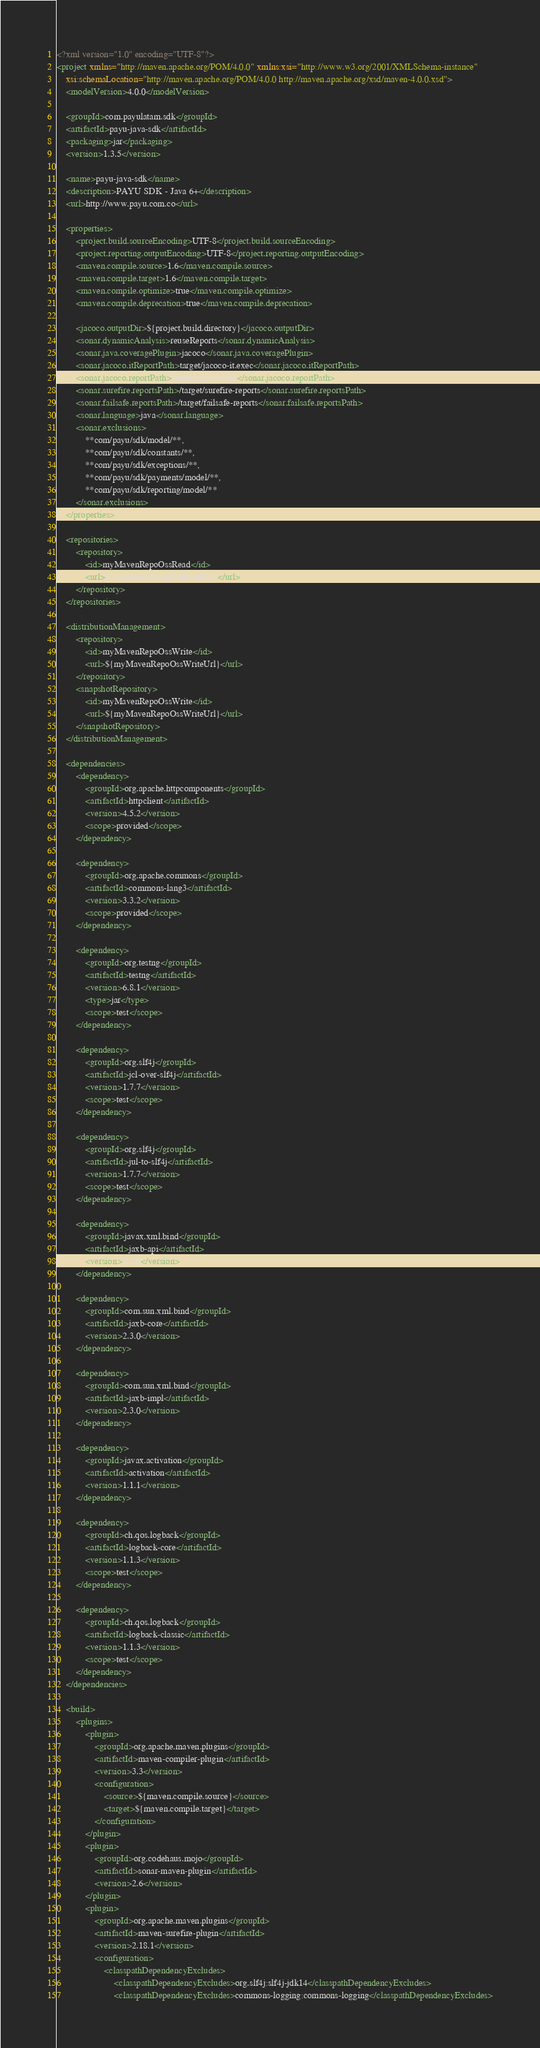Convert code to text. <code><loc_0><loc_0><loc_500><loc_500><_XML_><?xml version="1.0" encoding="UTF-8"?>
<project xmlns="http://maven.apache.org/POM/4.0.0" xmlns:xsi="http://www.w3.org/2001/XMLSchema-instance"
	xsi:schemaLocation="http://maven.apache.org/POM/4.0.0 http://maven.apache.org/xsd/maven-4.0.0.xsd">
	<modelVersion>4.0.0</modelVersion>

	<groupId>com.payulatam.sdk</groupId>
	<artifactId>payu-java-sdk</artifactId>
	<packaging>jar</packaging>
	<version>1.3.5</version>

	<name>payu-java-sdk</name>
	<description>PAYU SDK - Java 6+</description>
	<url>http://www.payu.com.co</url>

	<properties>
		<project.build.sourceEncoding>UTF-8</project.build.sourceEncoding>
		<project.reporting.outputEncoding>UTF-8</project.reporting.outputEncoding>
		<maven.compile.source>1.6</maven.compile.source>
		<maven.compile.target>1.6</maven.compile.target>
		<maven.compile.optimize>true</maven.compile.optimize>
		<maven.compile.deprecation>true</maven.compile.deprecation>

		<jacoco.outputDir>${project.build.directory}</jacoco.outputDir>
		<sonar.dynamicAnalysis>reuseReports</sonar.dynamicAnalysis>
		<sonar.java.coveragePlugin>jacoco</sonar.java.coveragePlugin>
		<sonar.jacoco.itReportPath>target/jacoco-it.exec</sonar.jacoco.itReportPath>
		<sonar.jacoco.reportPath>target/jacoco.exec</sonar.jacoco.reportPath>
		<sonar.surefire.reportsPath>/target/surefire-reports</sonar.surefire.reportsPath>
		<sonar.failsafe.reportsPath>/target/failsafe-reports</sonar.failsafe.reportsPath>
		<sonar.language>java</sonar.language>
		<sonar.exclusions>
			**com/payu/sdk/model/**,
			**com/payu/sdk/constants/**,
			**com/payu/sdk/exceptions/**,
			**com/payu/sdk/payments/model/**,
			**com/payu/sdk/reporting/model/**
		</sonar.exclusions>
	</properties>

	<repositories>
		<repository>
			<id>myMavenRepoOssRead</id>
			<url>${myMavenRepoOssReadUrl}</url>
		</repository>
	</repositories>

	<distributionManagement>
		<repository>
			<id>myMavenRepoOssWrite</id>
			<url>${myMavenRepoOssWriteUrl}</url>
		</repository>
		<snapshotRepository>
			<id>myMavenRepoOssWrite</id>
			<url>${myMavenRepoOssWriteUrl}</url>
		</snapshotRepository>
	</distributionManagement>

	<dependencies>
		<dependency>
			<groupId>org.apache.httpcomponents</groupId>
			<artifactId>httpclient</artifactId>
			<version>4.5.2</version>
			<scope>provided</scope>
		</dependency>

		<dependency>
			<groupId>org.apache.commons</groupId>
			<artifactId>commons-lang3</artifactId>
			<version>3.3.2</version>
			<scope>provided</scope>
		</dependency>

		<dependency>
			<groupId>org.testng</groupId>
			<artifactId>testng</artifactId>
			<version>6.8.1</version>
			<type>jar</type>
			<scope>test</scope>
		</dependency>

		<dependency>
			<groupId>org.slf4j</groupId>
			<artifactId>jcl-over-slf4j</artifactId>
			<version>1.7.7</version>
			<scope>test</scope>
		</dependency>

		<dependency>
			<groupId>org.slf4j</groupId>
			<artifactId>jul-to-slf4j</artifactId>
			<version>1.7.7</version>
			<scope>test</scope>
		</dependency>

		<dependency>
			<groupId>javax.xml.bind</groupId>
			<artifactId>jaxb-api</artifactId>
			<version>2.3.0</version>
		</dependency>

		<dependency>
			<groupId>com.sun.xml.bind</groupId>
			<artifactId>jaxb-core</artifactId>
			<version>2.3.0</version>
		</dependency>

		<dependency>
			<groupId>com.sun.xml.bind</groupId>
			<artifactId>jaxb-impl</artifactId>
			<version>2.3.0</version>
		</dependency>

		<dependency>
			<groupId>javax.activation</groupId>
			<artifactId>activation</artifactId>
			<version>1.1.1</version>
		</dependency>

		<dependency>
			<groupId>ch.qos.logback</groupId>
			<artifactId>logback-core</artifactId>
			<version>1.1.3</version>
			<scope>test</scope>
		</dependency>

		<dependency>
			<groupId>ch.qos.logback</groupId>
			<artifactId>logback-classic</artifactId>
			<version>1.1.3</version>
			<scope>test</scope>
		</dependency>
	</dependencies>

	<build>
		<plugins>
			<plugin>
				<groupId>org.apache.maven.plugins</groupId>
				<artifactId>maven-compiler-plugin</artifactId>
				<version>3.3</version>
				<configuration>
					<source>${maven.compile.source}</source>
					<target>${maven.compile.target}</target>
				</configuration>
			</plugin>
			<plugin>
				<groupId>org.codehaus.mojo</groupId>
				<artifactId>sonar-maven-plugin</artifactId>
				<version>2.6</version>
			</plugin>
			<plugin>
				<groupId>org.apache.maven.plugins</groupId>
				<artifactId>maven-surefire-plugin</artifactId>
				<version>2.18.1</version>
				<configuration>
					<classpathDependencyExcludes>
						<classpathDependencyExcludes>org.slf4j:slf4j-jdk14</classpathDependencyExcludes>
						<classpathDependencyExcludes>commons-logging:commons-logging</classpathDependencyExcludes></code> 